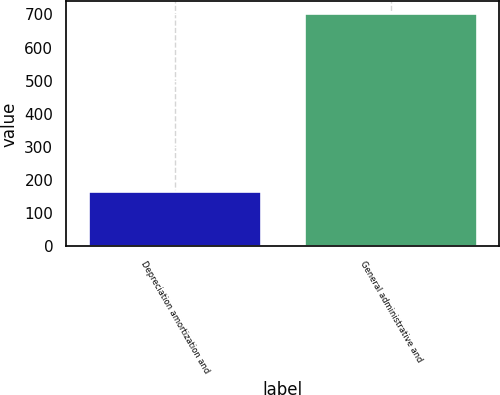Convert chart. <chart><loc_0><loc_0><loc_500><loc_500><bar_chart><fcel>Depreciation amortization and<fcel>General administrative and<nl><fcel>168<fcel>704<nl></chart> 